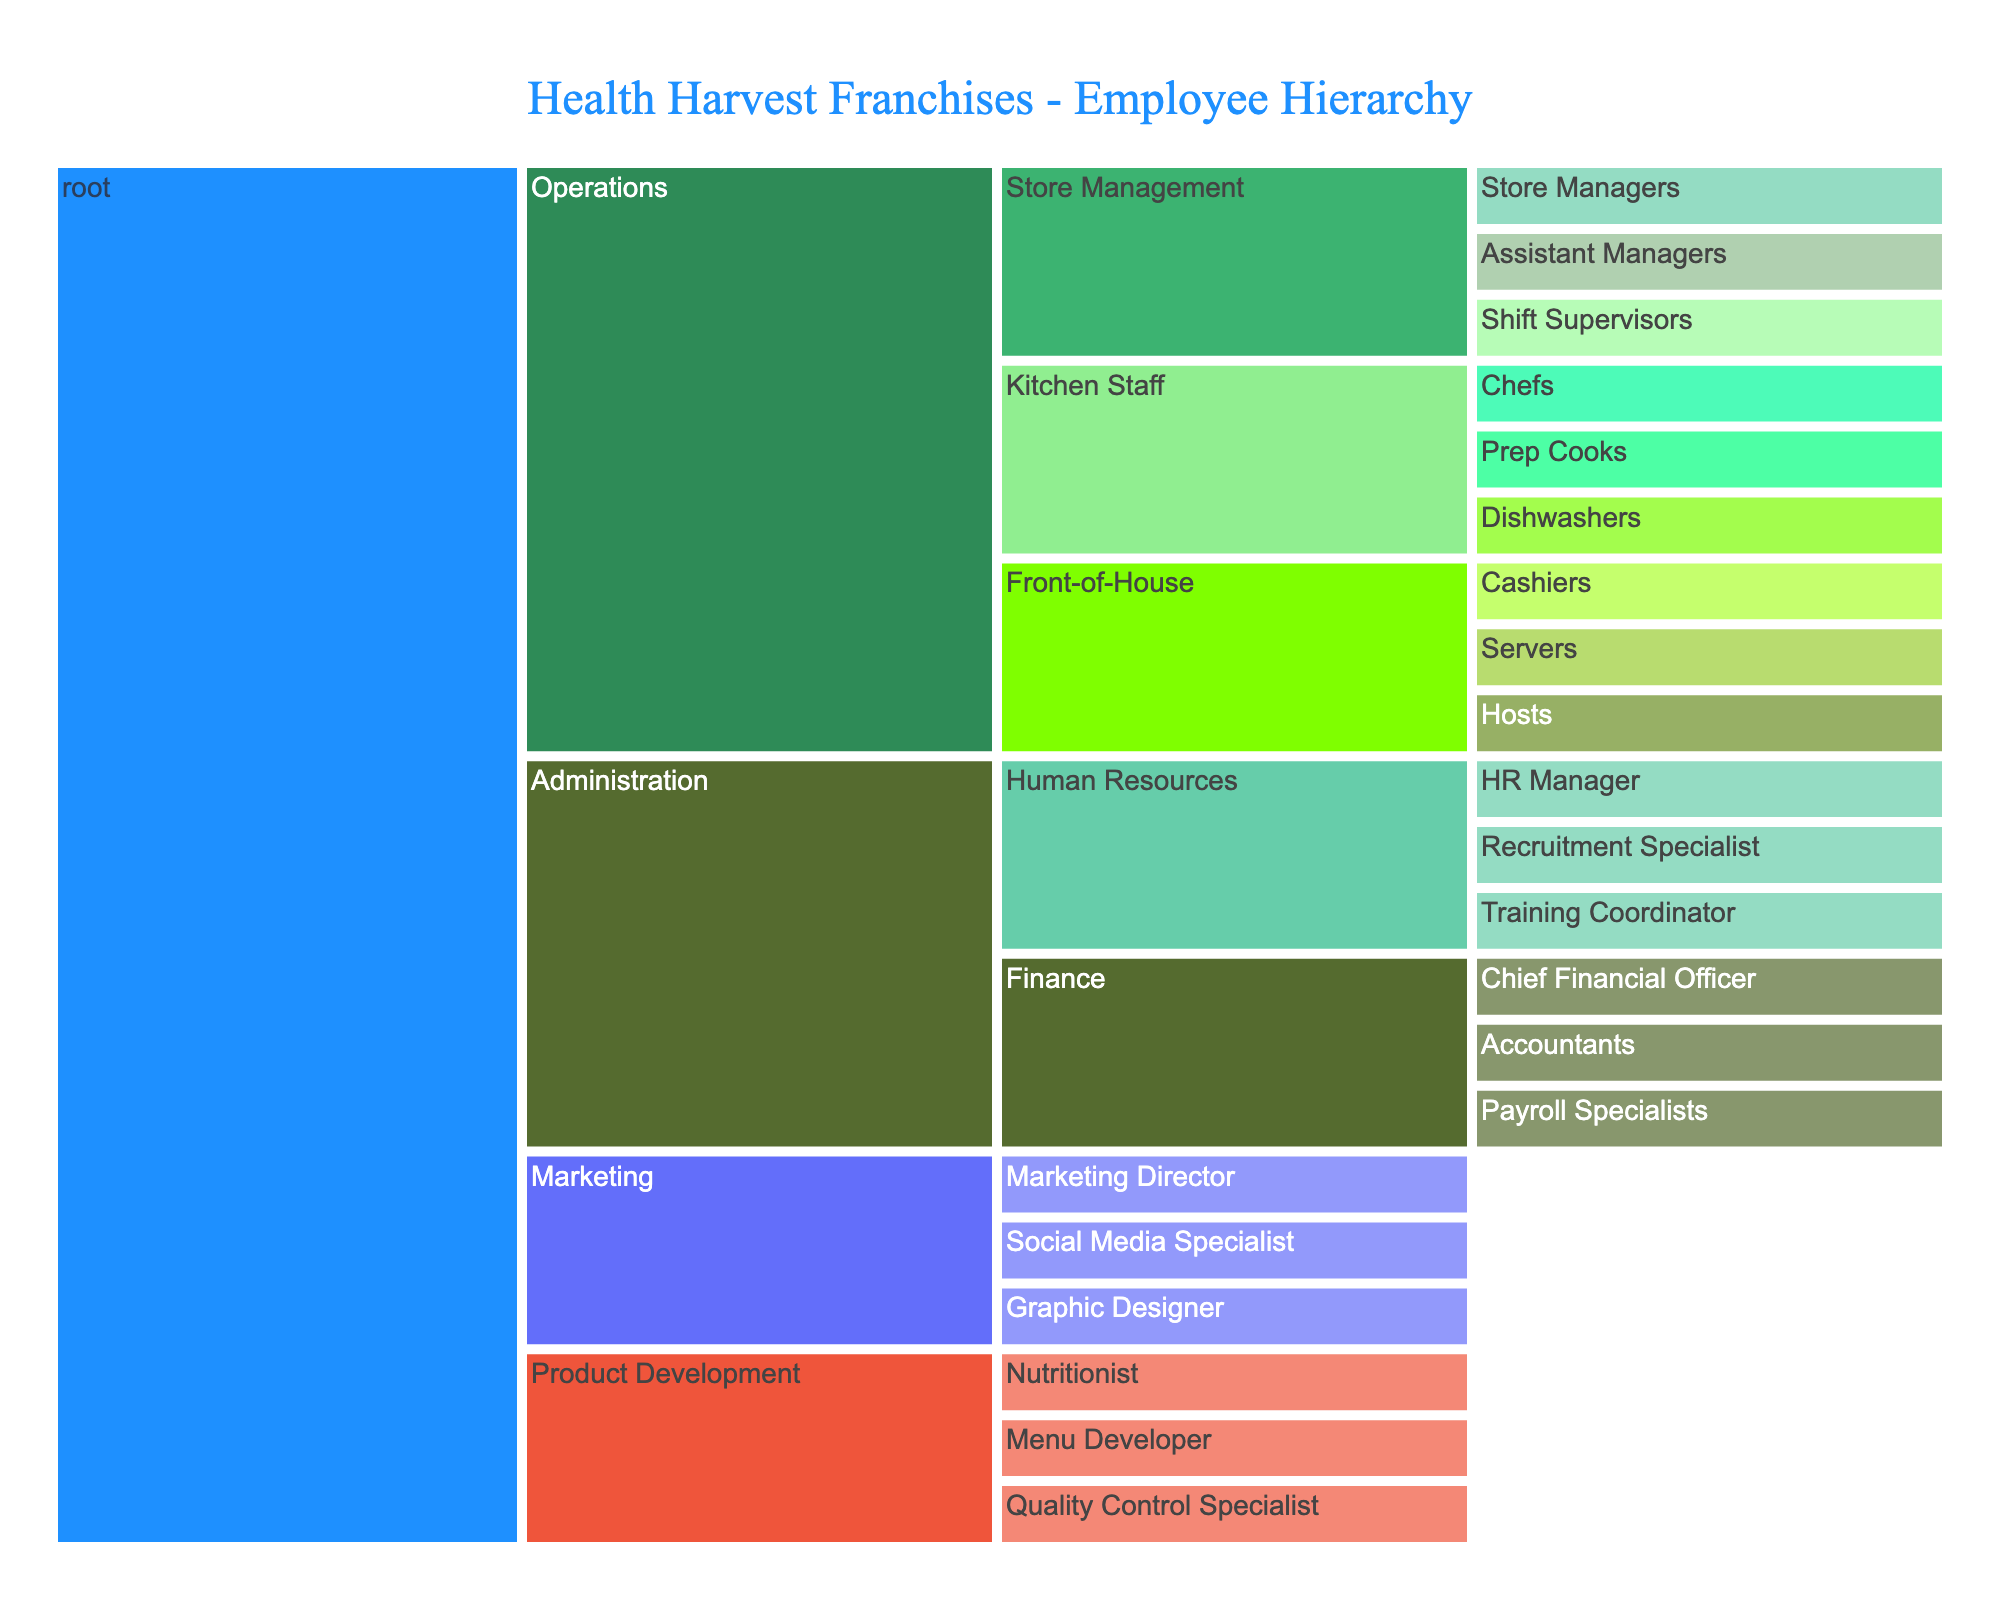What is the title of the Icicle Chart? The title is displayed at the top of the chart and reads "Health Harvest Franchises - Employee Hierarchy".
Answer: Health Harvest Franchises - Employee Hierarchy Which department has the most subcategories? By observing the number of branches under each department, Administration has the most subcategories with Finance and Human Resources each having their own subbranches.
Answer: Administration How many kitchen staff positions are listed? The Kitchen Staff node splits into three positions. These are Chefs, Prep Cooks, and Dishwashers.
Answer: 3 Who oversees the Marketing department? The node for Marketing branches directly into Marketing Director, which indicates the head of the Marketing department.
Answer: Marketing Director List all the roles under the Store Management subcategory. By following the branches under Store Management, we can see the roles are Store Managers, Assistant Managers, and Shift Supervisors.
Answer: Store Managers, Assistant Managers, Shift Supervisors Which subcategory has more roles: Human Resources or Front-of-House? Human Resources has three roles (HR Manager, Recruitment Specialist, Training Coordinator) while Front-of-House has three roles (Cashiers, Servers, Hosts). Compare the counts to see they are equal.
Answer: Equal How many total subcategories does the Operations department have, including all levels? Operations branches into three primary subcategories: Store Management, Kitchen Staff, and Front-of-House. Each of these has their own subcategories. Store Management has three roles, Kitchen Staff has three roles, and Front-of-House has three roles. Summing these, we get 3 + 3 + 3 = 9.
Answer: 9 Which subcategories exist directly under the Administration category? Directly under Administration, we have Human Resources and Finance.
Answer: Human Resources, Finance Who is responsible for Payroll in the franchise? Following the branches under Finance, one of them is Payroll Specialists. They are responsible for payroll.
Answer: Payroll Specialists Who directly reports to the Human Resources Manager? The Human Resources branch splits into HR Manager, Recruitment Specialist, and Training Coordinator. Only Recruitment Specialist and Training Coordinator would be reporting to the HR Manager.
Answer: Recruitment Specialist, Training Coordinator 